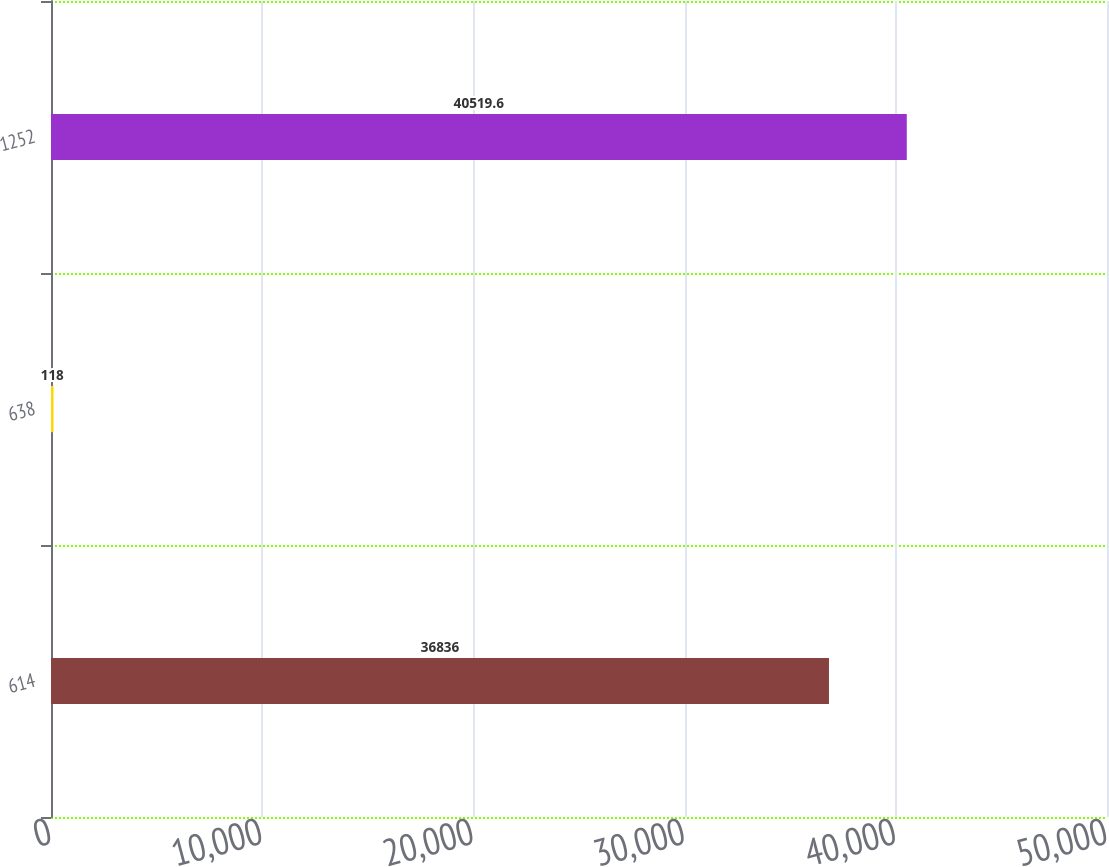<chart> <loc_0><loc_0><loc_500><loc_500><bar_chart><fcel>614<fcel>638<fcel>1252<nl><fcel>36836<fcel>118<fcel>40519.6<nl></chart> 